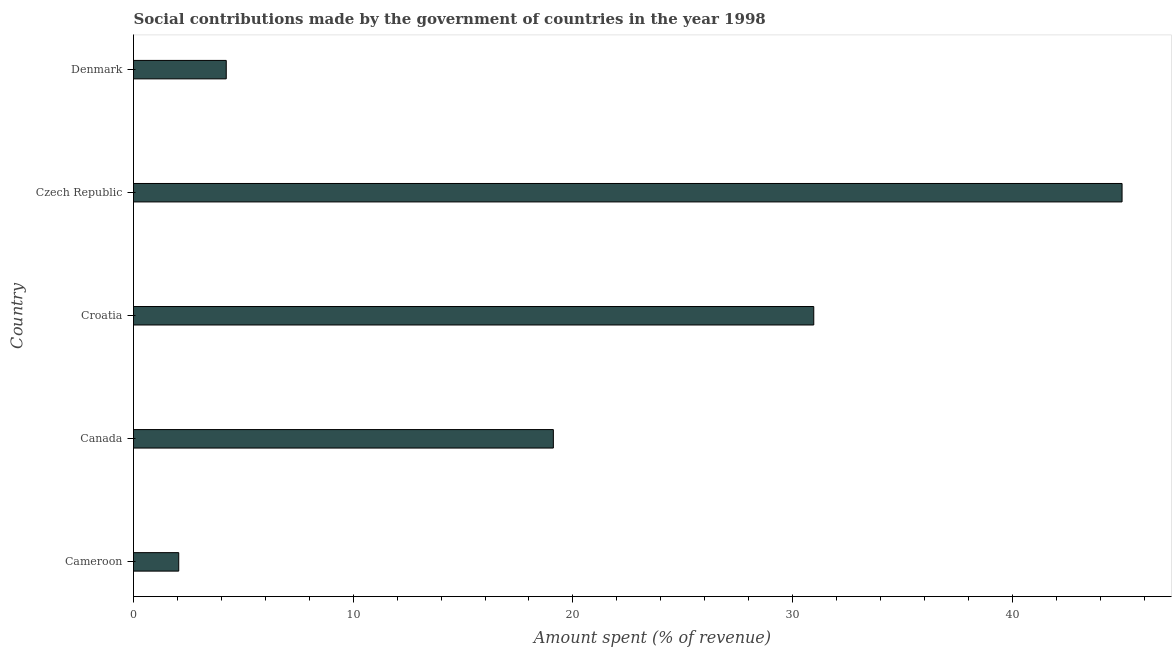What is the title of the graph?
Make the answer very short. Social contributions made by the government of countries in the year 1998. What is the label or title of the X-axis?
Provide a short and direct response. Amount spent (% of revenue). What is the label or title of the Y-axis?
Ensure brevity in your answer.  Country. What is the amount spent in making social contributions in Canada?
Your answer should be compact. 19.11. Across all countries, what is the maximum amount spent in making social contributions?
Give a very brief answer. 44.99. Across all countries, what is the minimum amount spent in making social contributions?
Give a very brief answer. 2.06. In which country was the amount spent in making social contributions maximum?
Your answer should be very brief. Czech Republic. In which country was the amount spent in making social contributions minimum?
Keep it short and to the point. Cameroon. What is the sum of the amount spent in making social contributions?
Provide a succinct answer. 101.34. What is the difference between the amount spent in making social contributions in Cameroon and Denmark?
Offer a terse response. -2.16. What is the average amount spent in making social contributions per country?
Your response must be concise. 20.27. What is the median amount spent in making social contributions?
Offer a terse response. 19.11. What is the ratio of the amount spent in making social contributions in Cameroon to that in Canada?
Give a very brief answer. 0.11. Is the difference between the amount spent in making social contributions in Czech Republic and Denmark greater than the difference between any two countries?
Ensure brevity in your answer.  No. What is the difference between the highest and the second highest amount spent in making social contributions?
Provide a succinct answer. 14.03. What is the difference between the highest and the lowest amount spent in making social contributions?
Give a very brief answer. 42.94. How many countries are there in the graph?
Offer a very short reply. 5. Are the values on the major ticks of X-axis written in scientific E-notation?
Provide a short and direct response. No. What is the Amount spent (% of revenue) in Cameroon?
Provide a succinct answer. 2.06. What is the Amount spent (% of revenue) in Canada?
Keep it short and to the point. 19.11. What is the Amount spent (% of revenue) in Croatia?
Your answer should be compact. 30.96. What is the Amount spent (% of revenue) of Czech Republic?
Provide a succinct answer. 44.99. What is the Amount spent (% of revenue) of Denmark?
Your response must be concise. 4.22. What is the difference between the Amount spent (% of revenue) in Cameroon and Canada?
Make the answer very short. -17.05. What is the difference between the Amount spent (% of revenue) in Cameroon and Croatia?
Keep it short and to the point. -28.9. What is the difference between the Amount spent (% of revenue) in Cameroon and Czech Republic?
Your answer should be compact. -42.94. What is the difference between the Amount spent (% of revenue) in Cameroon and Denmark?
Give a very brief answer. -2.16. What is the difference between the Amount spent (% of revenue) in Canada and Croatia?
Provide a succinct answer. -11.85. What is the difference between the Amount spent (% of revenue) in Canada and Czech Republic?
Your answer should be compact. -25.88. What is the difference between the Amount spent (% of revenue) in Canada and Denmark?
Make the answer very short. 14.89. What is the difference between the Amount spent (% of revenue) in Croatia and Czech Republic?
Provide a succinct answer. -14.03. What is the difference between the Amount spent (% of revenue) in Croatia and Denmark?
Your answer should be very brief. 26.74. What is the difference between the Amount spent (% of revenue) in Czech Republic and Denmark?
Your answer should be compact. 40.77. What is the ratio of the Amount spent (% of revenue) in Cameroon to that in Canada?
Make the answer very short. 0.11. What is the ratio of the Amount spent (% of revenue) in Cameroon to that in Croatia?
Offer a very short reply. 0.07. What is the ratio of the Amount spent (% of revenue) in Cameroon to that in Czech Republic?
Your answer should be compact. 0.05. What is the ratio of the Amount spent (% of revenue) in Cameroon to that in Denmark?
Provide a succinct answer. 0.49. What is the ratio of the Amount spent (% of revenue) in Canada to that in Croatia?
Provide a short and direct response. 0.62. What is the ratio of the Amount spent (% of revenue) in Canada to that in Czech Republic?
Make the answer very short. 0.42. What is the ratio of the Amount spent (% of revenue) in Canada to that in Denmark?
Make the answer very short. 4.53. What is the ratio of the Amount spent (% of revenue) in Croatia to that in Czech Republic?
Give a very brief answer. 0.69. What is the ratio of the Amount spent (% of revenue) in Croatia to that in Denmark?
Provide a short and direct response. 7.33. What is the ratio of the Amount spent (% of revenue) in Czech Republic to that in Denmark?
Provide a succinct answer. 10.66. 